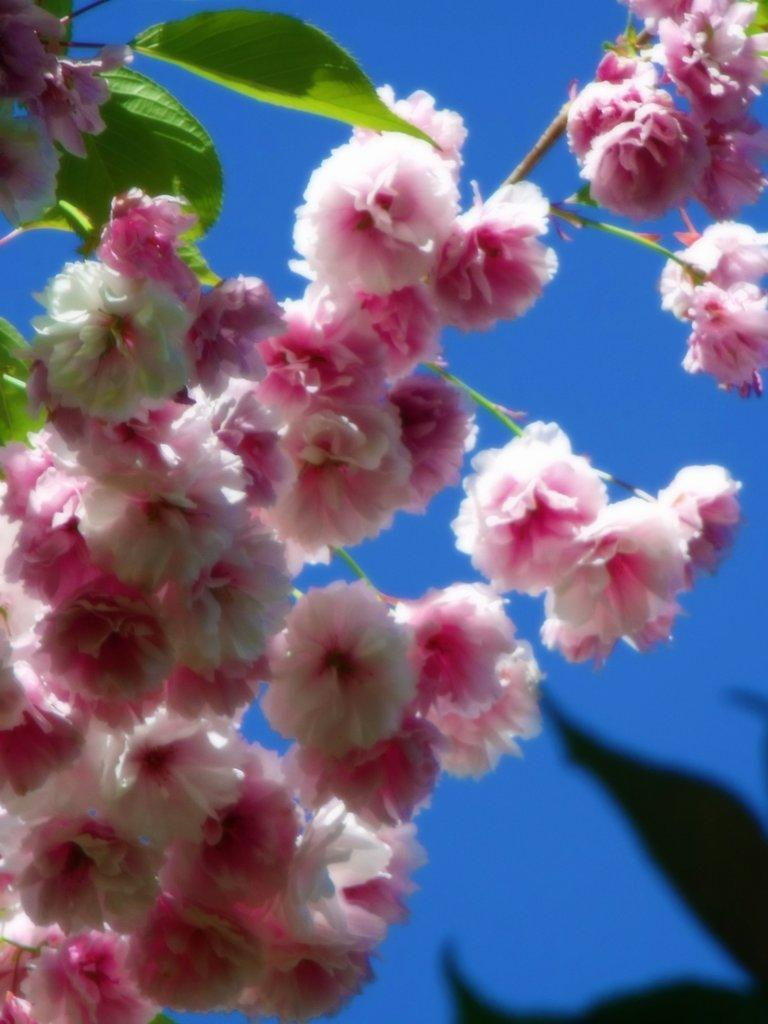What type of plant elements can be seen in the image? There are flowers, leaves, and stems in the image. Can you describe the flowers in the image? The flowers in the image have various colors and shapes. What is the purpose of the stems in the image? The stems in the image provide support for the flowers and leaves. How does the earthquake affect the balance of the flowers in the image? There is no earthquake present in the image, so its effects on the flowers cannot be determined. 